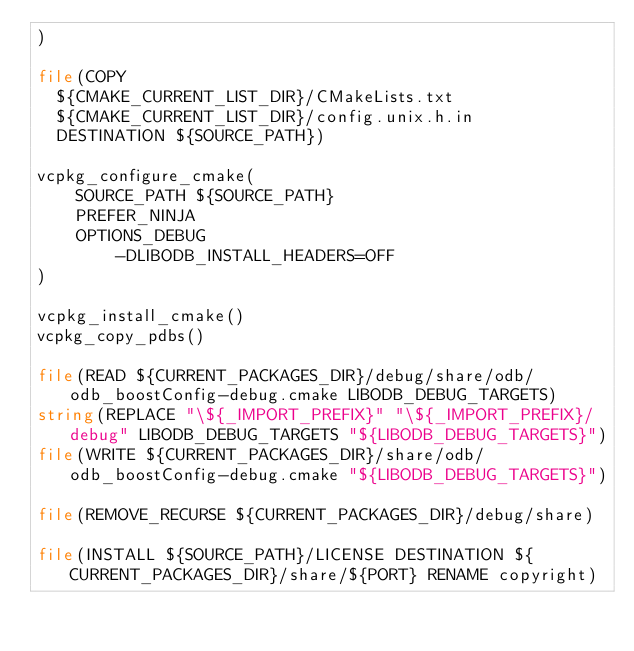<code> <loc_0><loc_0><loc_500><loc_500><_CMake_>)

file(COPY
  ${CMAKE_CURRENT_LIST_DIR}/CMakeLists.txt
  ${CMAKE_CURRENT_LIST_DIR}/config.unix.h.in
  DESTINATION ${SOURCE_PATH})

vcpkg_configure_cmake(
    SOURCE_PATH ${SOURCE_PATH}
    PREFER_NINJA
    OPTIONS_DEBUG
        -DLIBODB_INSTALL_HEADERS=OFF
)

vcpkg_install_cmake()
vcpkg_copy_pdbs()

file(READ ${CURRENT_PACKAGES_DIR}/debug/share/odb/odb_boostConfig-debug.cmake LIBODB_DEBUG_TARGETS)
string(REPLACE "\${_IMPORT_PREFIX}" "\${_IMPORT_PREFIX}/debug" LIBODB_DEBUG_TARGETS "${LIBODB_DEBUG_TARGETS}")
file(WRITE ${CURRENT_PACKAGES_DIR}/share/odb/odb_boostConfig-debug.cmake "${LIBODB_DEBUG_TARGETS}")

file(REMOVE_RECURSE ${CURRENT_PACKAGES_DIR}/debug/share)

file(INSTALL ${SOURCE_PATH}/LICENSE DESTINATION ${CURRENT_PACKAGES_DIR}/share/${PORT} RENAME copyright)
</code> 